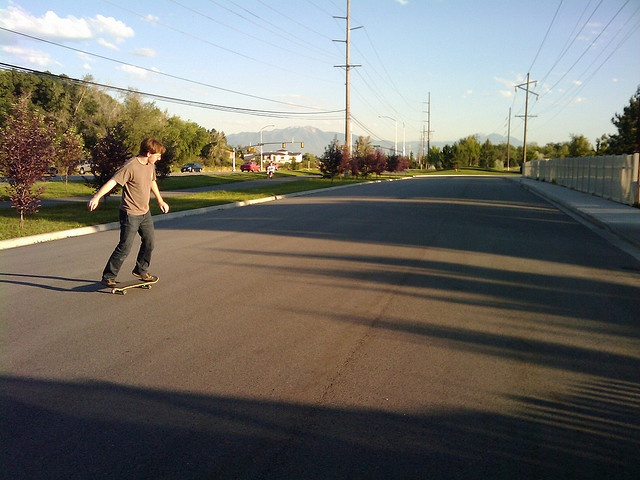Describe the objects in this image and their specific colors. I can see people in lightblue, black, gray, and tan tones, skateboard in lightblue, gray, olive, and maroon tones, car in lightblue, black, gray, maroon, and olive tones, car in lightblue, maroon, black, lightpink, and gray tones, and traffic light in lightblue, tan, yellow, brown, and gray tones in this image. 